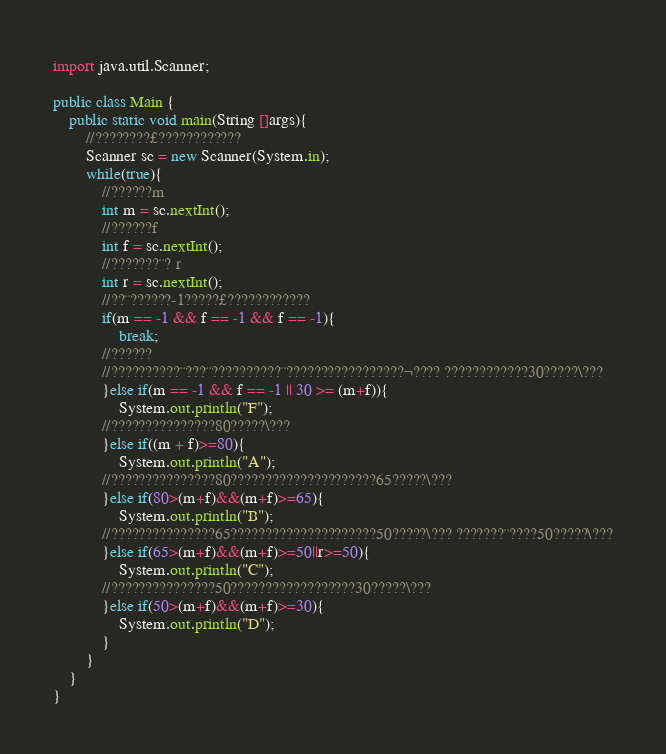<code> <loc_0><loc_0><loc_500><loc_500><_Java_>

import java.util.Scanner;

public class Main {
	public static void main(String []args){
		//????????£????????????
		Scanner sc = new Scanner(System.in);
		while(true){
			//??????m
			int m = sc.nextInt();
			//??????f
			int f = sc.nextInt();
			//???????¨? r
			int r = sc.nextInt();
			//??¨??????-1?????£????????????
			if(m == -1 && f == -1 && f == -1){
                break;
            //??????
            //??????????¨???¨??????????¨?????????????????¬???? ????????????30?????\???
			}else if(m == -1 && f == -1 || 30 >= (m+f)){
				System.out.println("F");
			//???????????????80?????\???
			}else if((m + f)>=80){
				System.out.println("A");
			//???????????????80?????????????????????65?????\???
			}else if(80>(m+f)&&(m+f)>=65){
				System.out.println("B");
			//???????????????65?????????????????????50?????\??? ???????¨????50?????\???
			}else if(65>(m+f)&&(m+f)>=50||r>=50){
				System.out.println("C");
			//???????????????50??????????????????30?????\??? 
			}else if(50>(m+f)&&(m+f)>=30){
				System.out.println("D");
			}
		}
    }
}</code> 